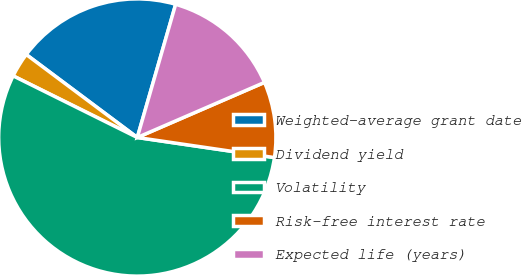Convert chart. <chart><loc_0><loc_0><loc_500><loc_500><pie_chart><fcel>Weighted-average grant date<fcel>Dividend yield<fcel>Volatility<fcel>Risk-free interest rate<fcel>Expected life (years)<nl><fcel>19.25%<fcel>2.88%<fcel>55.02%<fcel>8.82%<fcel>14.03%<nl></chart> 